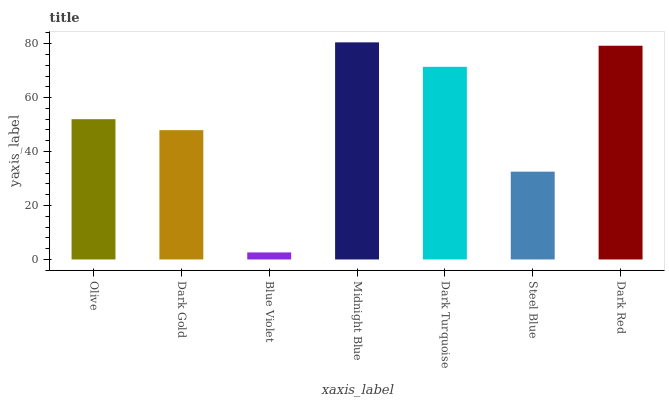Is Blue Violet the minimum?
Answer yes or no. Yes. Is Midnight Blue the maximum?
Answer yes or no. Yes. Is Dark Gold the minimum?
Answer yes or no. No. Is Dark Gold the maximum?
Answer yes or no. No. Is Olive greater than Dark Gold?
Answer yes or no. Yes. Is Dark Gold less than Olive?
Answer yes or no. Yes. Is Dark Gold greater than Olive?
Answer yes or no. No. Is Olive less than Dark Gold?
Answer yes or no. No. Is Olive the high median?
Answer yes or no. Yes. Is Olive the low median?
Answer yes or no. Yes. Is Blue Violet the high median?
Answer yes or no. No. Is Midnight Blue the low median?
Answer yes or no. No. 